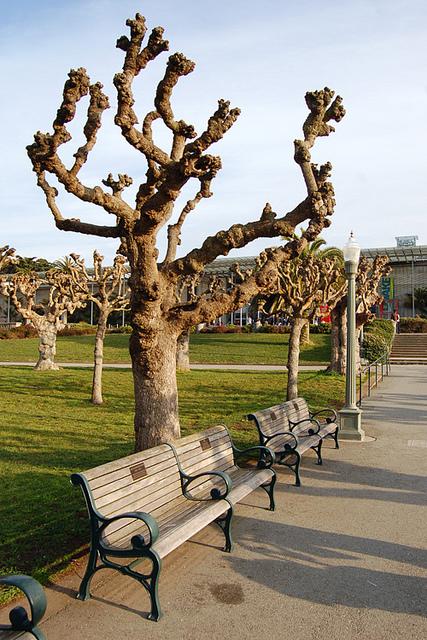What kind of trees are these?
Quick response, please. Joshua. How many benches are in the photo?
Write a very short answer. 3. Are there leaves on the trees?
Be succinct. No. 